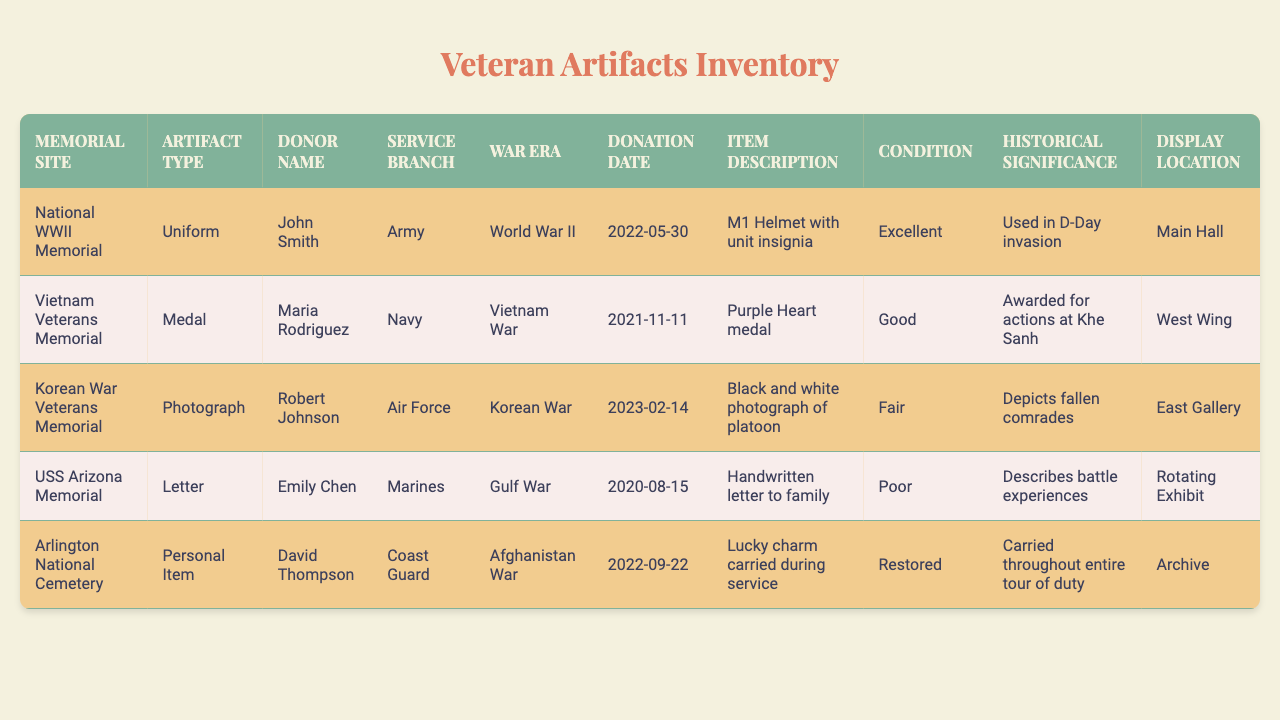What artifact was donated by John Smith? John Smith donated an M1 Helmet with unit insignia, which can be found under the "Item Description" column associated with his name.
Answer: M1 Helmet with unit insignia Which memorial site has the artifact type "Medal"? The "Vietnam Veterans Memorial" has the artifact type "Medal," as indicated in the table under the corresponding artifact type for that memorial site.
Answer: Vietnam Veterans Memorial How many artifacts are described as being in "Excellent" condition? There is one artifact described as in "Excellent" condition, which is the M1 Helmet from the National WWII Memorial. This can be verified in the "Condition" column in the table.
Answer: 1 What is the war era associated with the artifact donated by Maria Rodriguez? Maria Rodriguez's artifact, a Purple Heart medal, is associated with the Vietnam War as listed in the "War Era" column corresponding to her donation.
Answer: Vietnam War Which artifact was donated last? The last donation was made by Robert Johnson on February 14, 2023, which corresponds to the "Black and white photograph of platoon" mentioned in the "Item Description" column.
Answer: Black and white photograph of platoon Is there an artifact related to the Korean War? Yes, there is an artifact related to the Korean War, which is the black and white photograph donated by Robert Johnson as indicated in the table.
Answer: Yes Which artifact has a historical significance of depicting fallen comrades? The artifact depicting fallen comrades is the black and white photograph of the platoon donated by Robert Johnson. This can be confirmed by checking the "Historical Significance" column in the table.
Answer: Black and white photograph of platoon What is the most common artifact type found in the table? The artifact types listed are Uniform, Medal, Photograph, Letter, and Personal Item. Since all types only appear once, no single type dominates; therefore, there is no common type.
Answer: None How many different service branches are represented in the donations? There are five different service branches represented in the donations: Army, Navy, Air Force, Marines, and Coast Guard, as seen in the "Service Branch" column.
Answer: 5 If you take the "Poor" condition artifacts into account, how many are there? There is one artifact in "Poor" condition listed, which is the handwritten letter to family at the USS Arizona Memorial. This is confirmed by checking the "Condition" column.
Answer: 1 